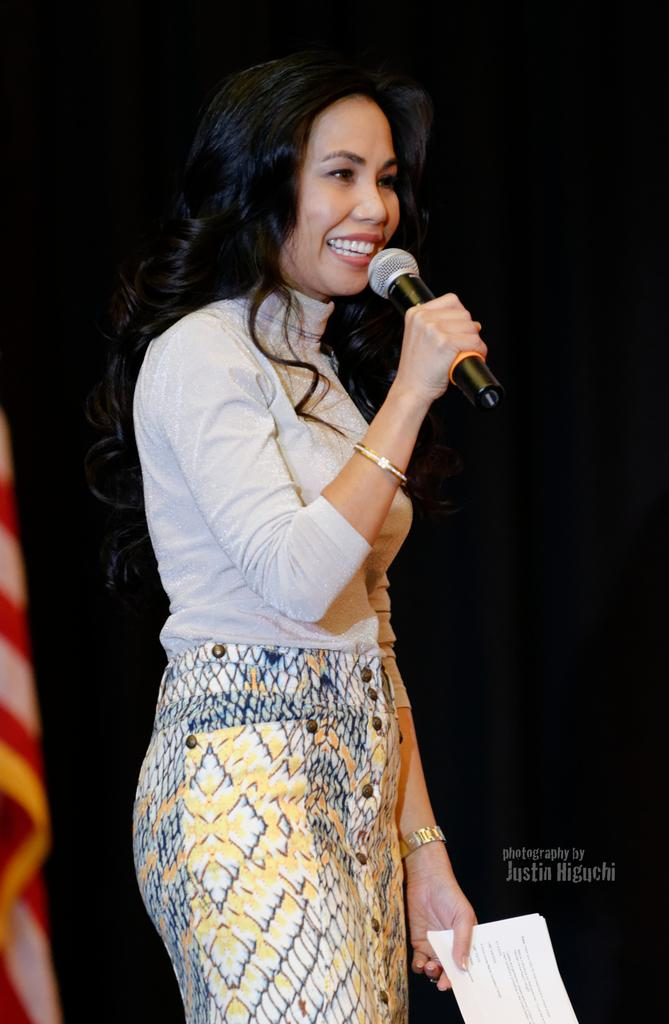Who is the main subject in the image? There is a woman in the image. What is the woman doing in the image? The woman is standing and holding a mic and a paper. What is the woman's facial expression in the image? The woman is smiling in the image. What can be observed about the background of the image? The background of the image is dark. What type of shoes is the woman wearing in the image? There is no information about the woman's shoes in the image, so we cannot determine what type she is wearing. 